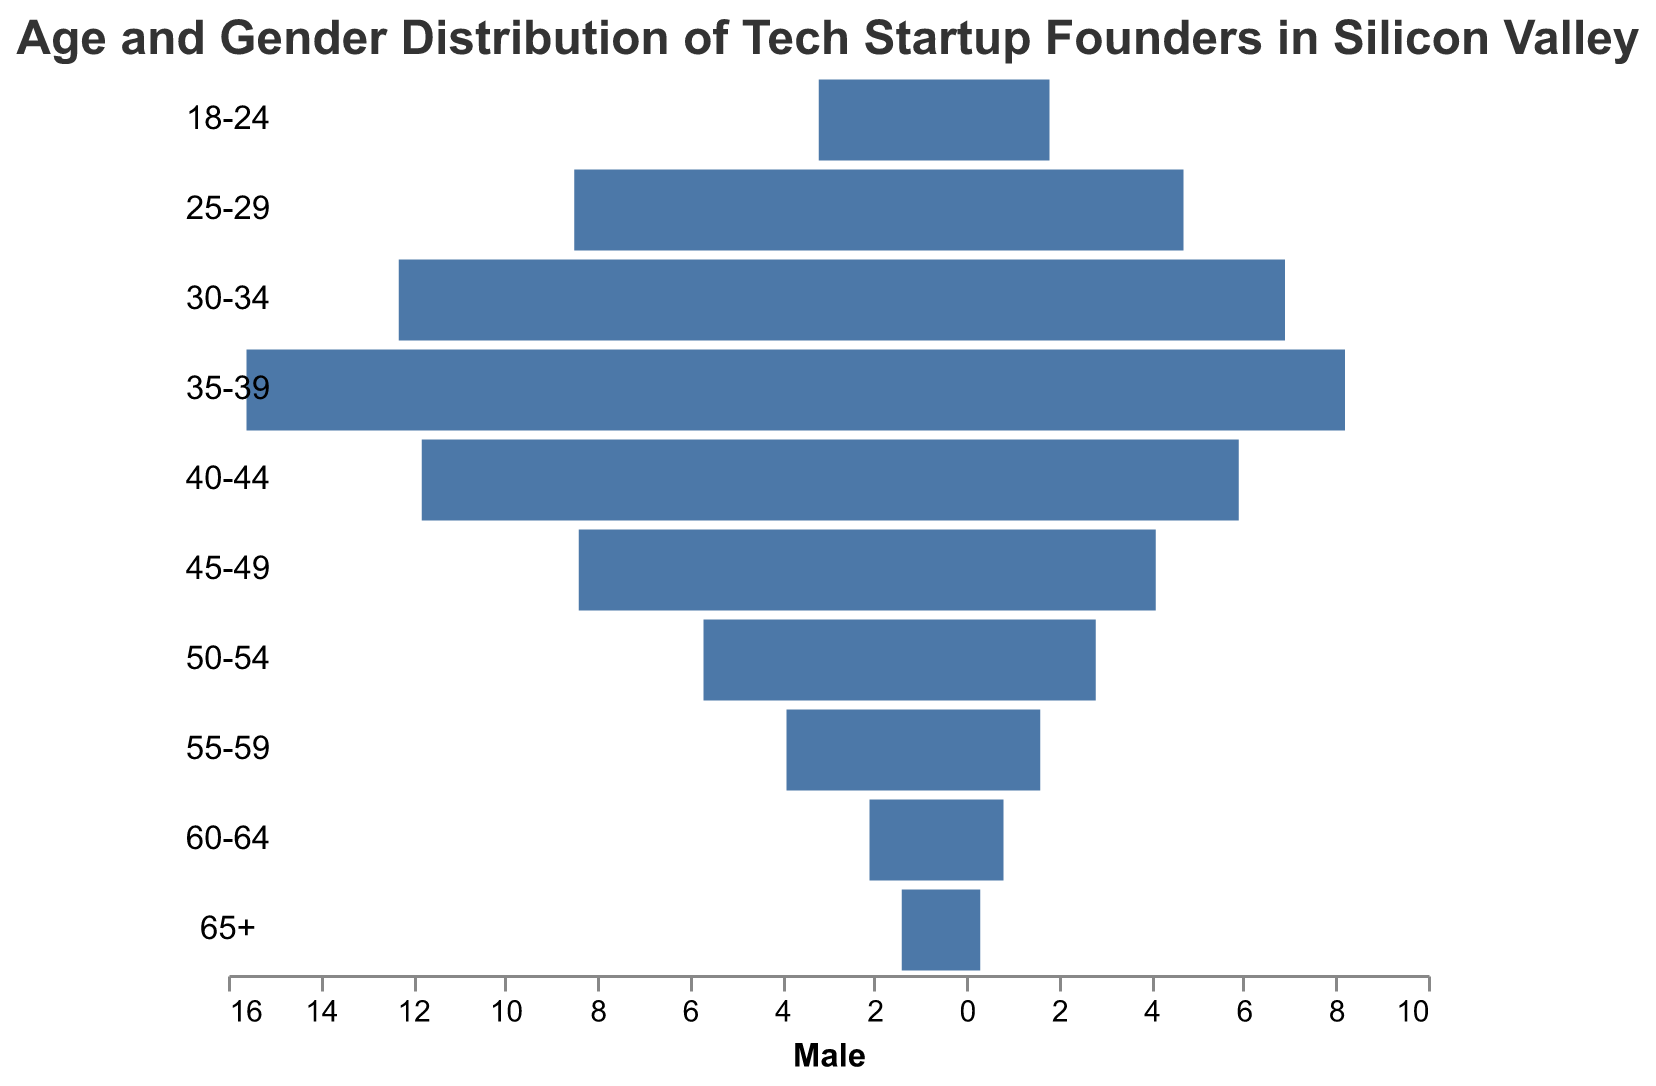How many age groups are shown in the population pyramid? The population pyramid shows the age groups listed on the y-axis. There are 10 age groups: "18-24", "25-29", "30-34", "35-39", "40-44", "45-49", "50-54", "55-59", "60-64", and "65+".
Answer: 10 What is the title of the population pyramid? The title is displayed at the top of the figure. It reads "Age and Gender Distribution of Tech Startup Founders in Silicon Valley".
Answer: Age and Gender Distribution of Tech Startup Founders in Silicon Valley In which age group is the number of male founders highest? By comparing the lengths of the blue bars (male) for each age group, the longest bar corresponds to the "35-39" age group, which has 15.6% male founders.
Answer: 35-39 How much higher is the percentage of female founders in the "35-39" age group compared to the "18-24" age group? The percentage of female founders in the "35-39" age group is 8.2%, and in the "18-24" age group it is 1.8%. The difference is 8.2% - 1.8% = 6.4%.
Answer: 6.4% Which age group has the smallest percentage of female founders? By observing the red bars (female) for each age group, the shortest bar corresponds to the "65+" age group, having 0.3% female founders.
Answer: 65+ What is the combined percentage of male and female founders in the "25-29" age group? The percentage of male founders in the "25-29" age group is 8.5%, and the percentage of female founders is 4.7%. The combined percentage is 8.5% + 4.7% = 13.2%.
Answer: 13.2% What is the ratio of male to female founders in the "30-34" age group? The percentage of male founders in the "30-34" age group is 12.3%, and the percentage of female founders is 6.9%. The ratio is calculated as 12.3 / 6.9, which simplifies approximately to 1.78.
Answer: 1.78 Which two consecutive age groups show the most significant drop in the percentage of female founders? Examining the red bars (female), we see the percentage drops from 8.2% in "35-39" to 5.9% in "40-44". The drop is 8.2% - 5.9% = 2.3%, which is the most significant drop in consecutive age groups.
Answer: 35-39 to 40-44 What is the sum of the percentages of male founders in the age groups "45-49" and "50-54"? The percentage of male founders in the "45-49" age group is 8.4%, and in the "50-54" age group it is 5.7%. The sum is 8.4% + 5.7% = 14.1%.
Answer: 14.1% In which age group is the gender disparity (difference between male and female percentages) the smallest? By comparing the differences between the male and female percentages for each age group, the smallest disparity is in the "25-29" age group, with a difference of 8.5% - 4.7% = 3.8%.
Answer: 25-29 